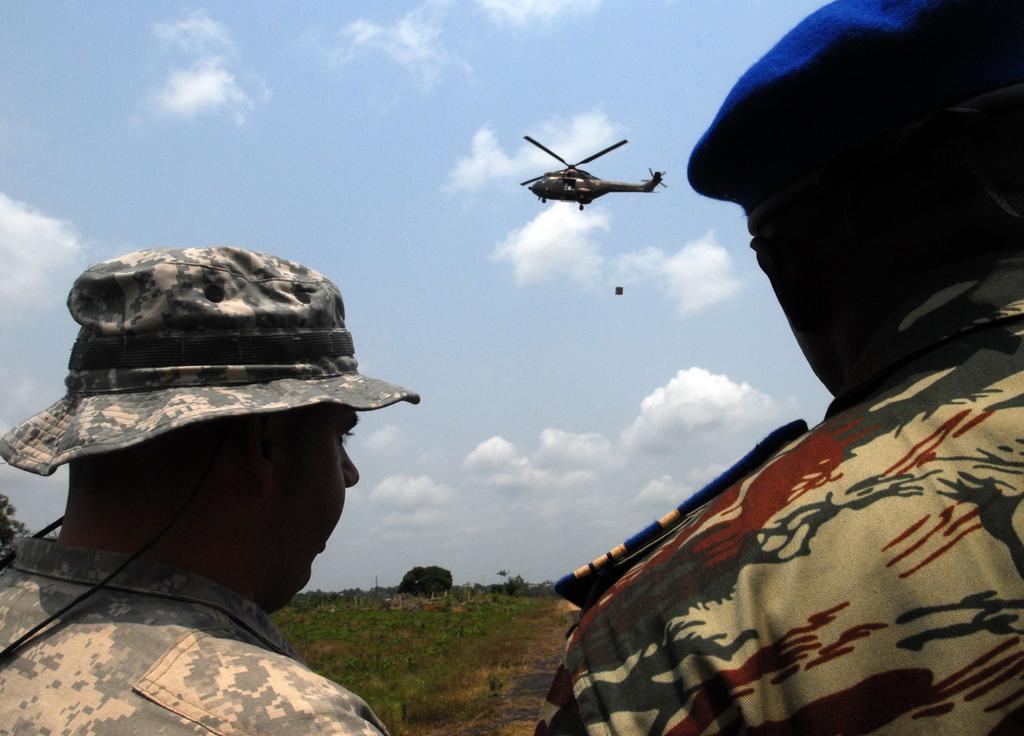Can you describe this image briefly? In this image in the foreground there are two persons who are wearing hats, and at the top there is helicopter and in the center there is some grass and walkway. And in the background there are some trees, at the top of the image there is sky. 